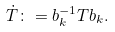Convert formula to latex. <formula><loc_0><loc_0><loc_500><loc_500>\dot { T } \colon = b _ { k } ^ { - 1 } T b _ { k } .</formula> 